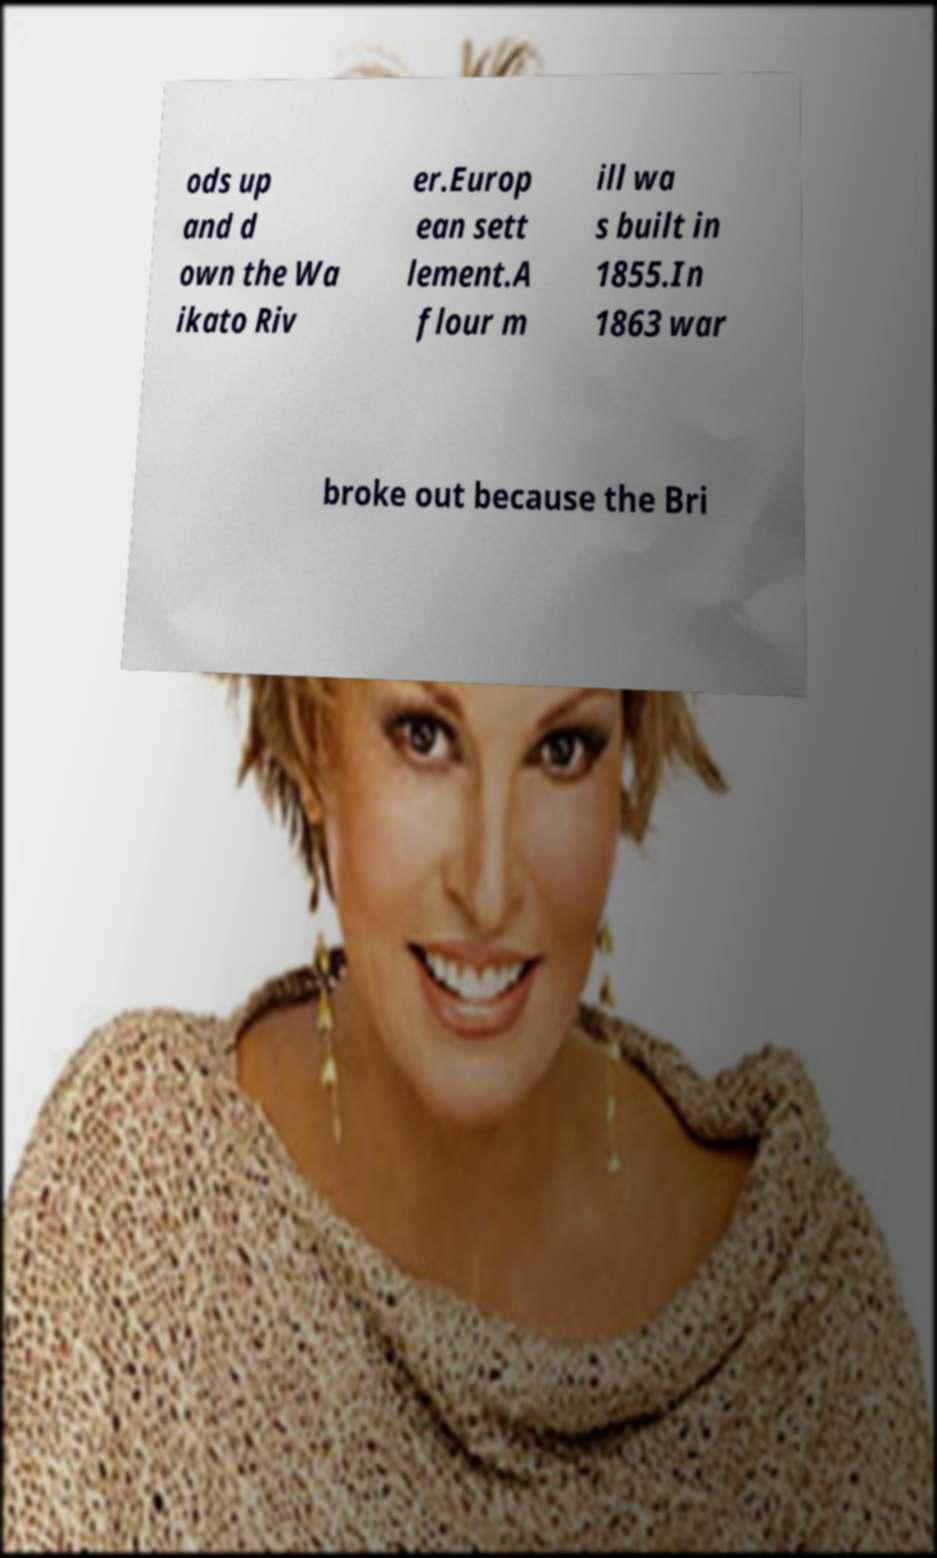What messages or text are displayed in this image? I need them in a readable, typed format. ods up and d own the Wa ikato Riv er.Europ ean sett lement.A flour m ill wa s built in 1855.In 1863 war broke out because the Bri 